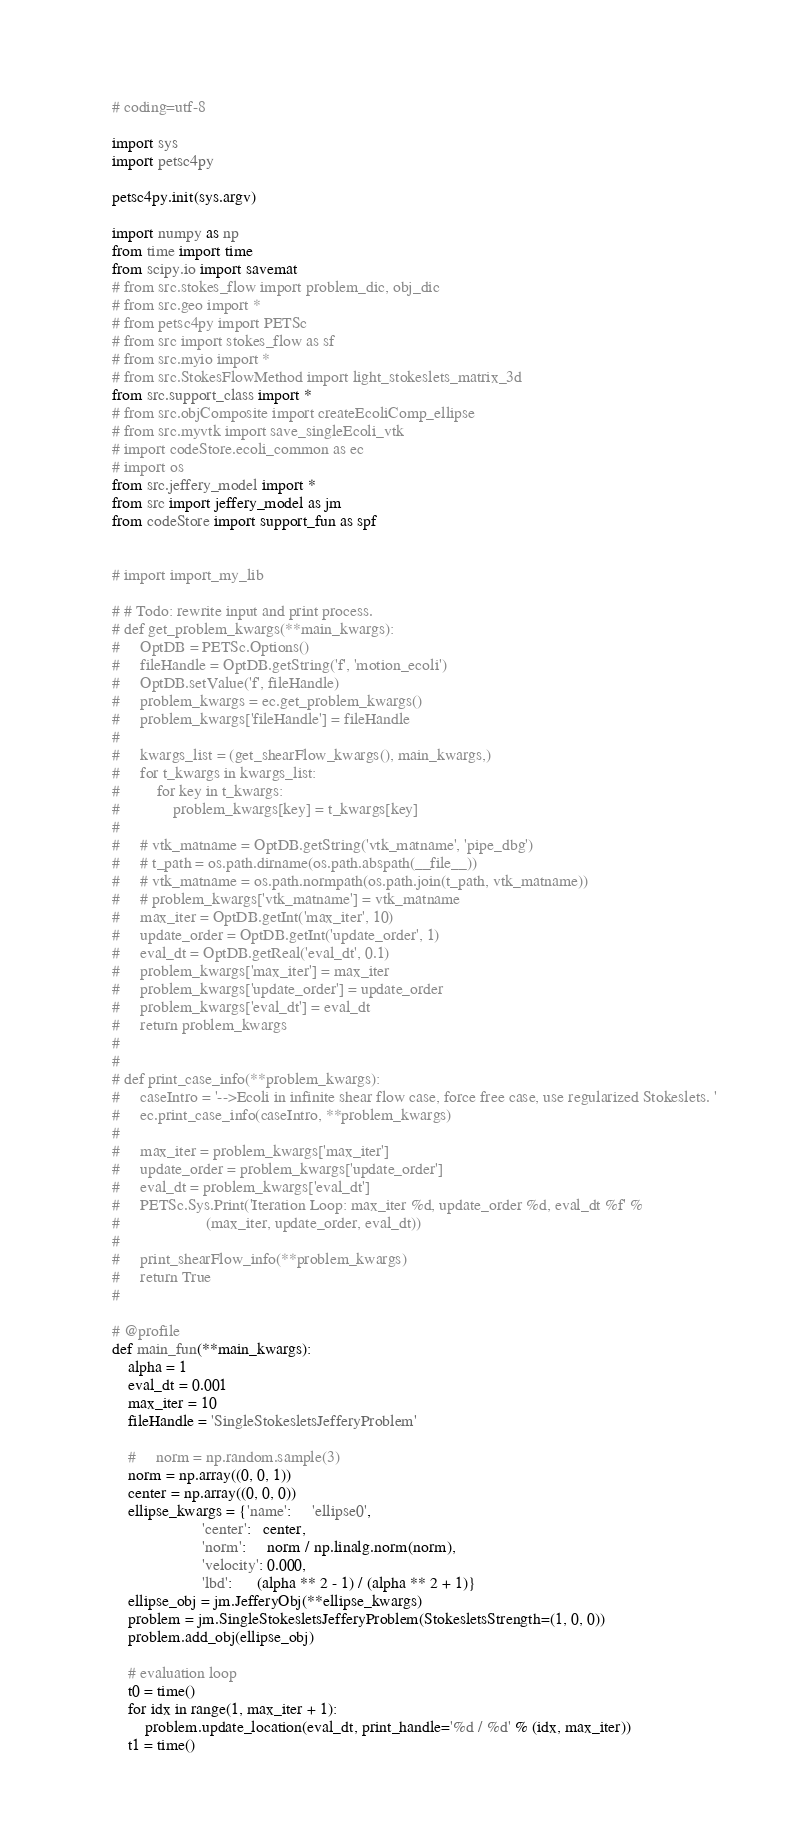Convert code to text. <code><loc_0><loc_0><loc_500><loc_500><_Python_># coding=utf-8

import sys
import petsc4py

petsc4py.init(sys.argv)

import numpy as np
from time import time
from scipy.io import savemat
# from src.stokes_flow import problem_dic, obj_dic
# from src.geo import *
# from petsc4py import PETSc
# from src import stokes_flow as sf
# from src.myio import *
# from src.StokesFlowMethod import light_stokeslets_matrix_3d
from src.support_class import *
# from src.objComposite import createEcoliComp_ellipse
# from src.myvtk import save_singleEcoli_vtk
# import codeStore.ecoli_common as ec
# import os
from src.jeffery_model import *
from src import jeffery_model as jm
from codeStore import support_fun as spf


# import import_my_lib

# # Todo: rewrite input and print process.
# def get_problem_kwargs(**main_kwargs):
#     OptDB = PETSc.Options()
#     fileHandle = OptDB.getString('f', 'motion_ecoli')
#     OptDB.setValue('f', fileHandle)
#     problem_kwargs = ec.get_problem_kwargs()
#     problem_kwargs['fileHandle'] = fileHandle
#
#     kwargs_list = (get_shearFlow_kwargs(), main_kwargs,)
#     for t_kwargs in kwargs_list:
#         for key in t_kwargs:
#             problem_kwargs[key] = t_kwargs[key]
#
#     # vtk_matname = OptDB.getString('vtk_matname', 'pipe_dbg')
#     # t_path = os.path.dirname(os.path.abspath(__file__))
#     # vtk_matname = os.path.normpath(os.path.join(t_path, vtk_matname))
#     # problem_kwargs['vtk_matname'] = vtk_matname
#     max_iter = OptDB.getInt('max_iter', 10)
#     update_order = OptDB.getInt('update_order', 1)
#     eval_dt = OptDB.getReal('eval_dt', 0.1)
#     problem_kwargs['max_iter'] = max_iter
#     problem_kwargs['update_order'] = update_order
#     problem_kwargs['eval_dt'] = eval_dt
#     return problem_kwargs
#
#
# def print_case_info(**problem_kwargs):
#     caseIntro = '-->Ecoli in infinite shear flow case, force free case, use regularized Stokeslets. '
#     ec.print_case_info(caseIntro, **problem_kwargs)
#
#     max_iter = problem_kwargs['max_iter']
#     update_order = problem_kwargs['update_order']
#     eval_dt = problem_kwargs['eval_dt']
#     PETSc.Sys.Print('Iteration Loop: max_iter %d, update_order %d, eval_dt %f' %
#                     (max_iter, update_order, eval_dt))
#
#     print_shearFlow_info(**problem_kwargs)
#     return True
#

# @profile
def main_fun(**main_kwargs):
    alpha = 1
    eval_dt = 0.001
    max_iter = 10
    fileHandle = 'SingleStokesletsJefferyProblem'

    #     norm = np.random.sample(3)
    norm = np.array((0, 0, 1))
    center = np.array((0, 0, 0))
    ellipse_kwargs = {'name':     'ellipse0',
                      'center':   center,
                      'norm':     norm / np.linalg.norm(norm),
                      'velocity': 0.000,
                      'lbd':      (alpha ** 2 - 1) / (alpha ** 2 + 1)}
    ellipse_obj = jm.JefferyObj(**ellipse_kwargs)
    problem = jm.SingleStokesletsJefferyProblem(StokesletsStrength=(1, 0, 0))
    problem.add_obj(ellipse_obj)

    # evaluation loop
    t0 = time()
    for idx in range(1, max_iter + 1):
        problem.update_location(eval_dt, print_handle='%d / %d' % (idx, max_iter))
    t1 = time()</code> 